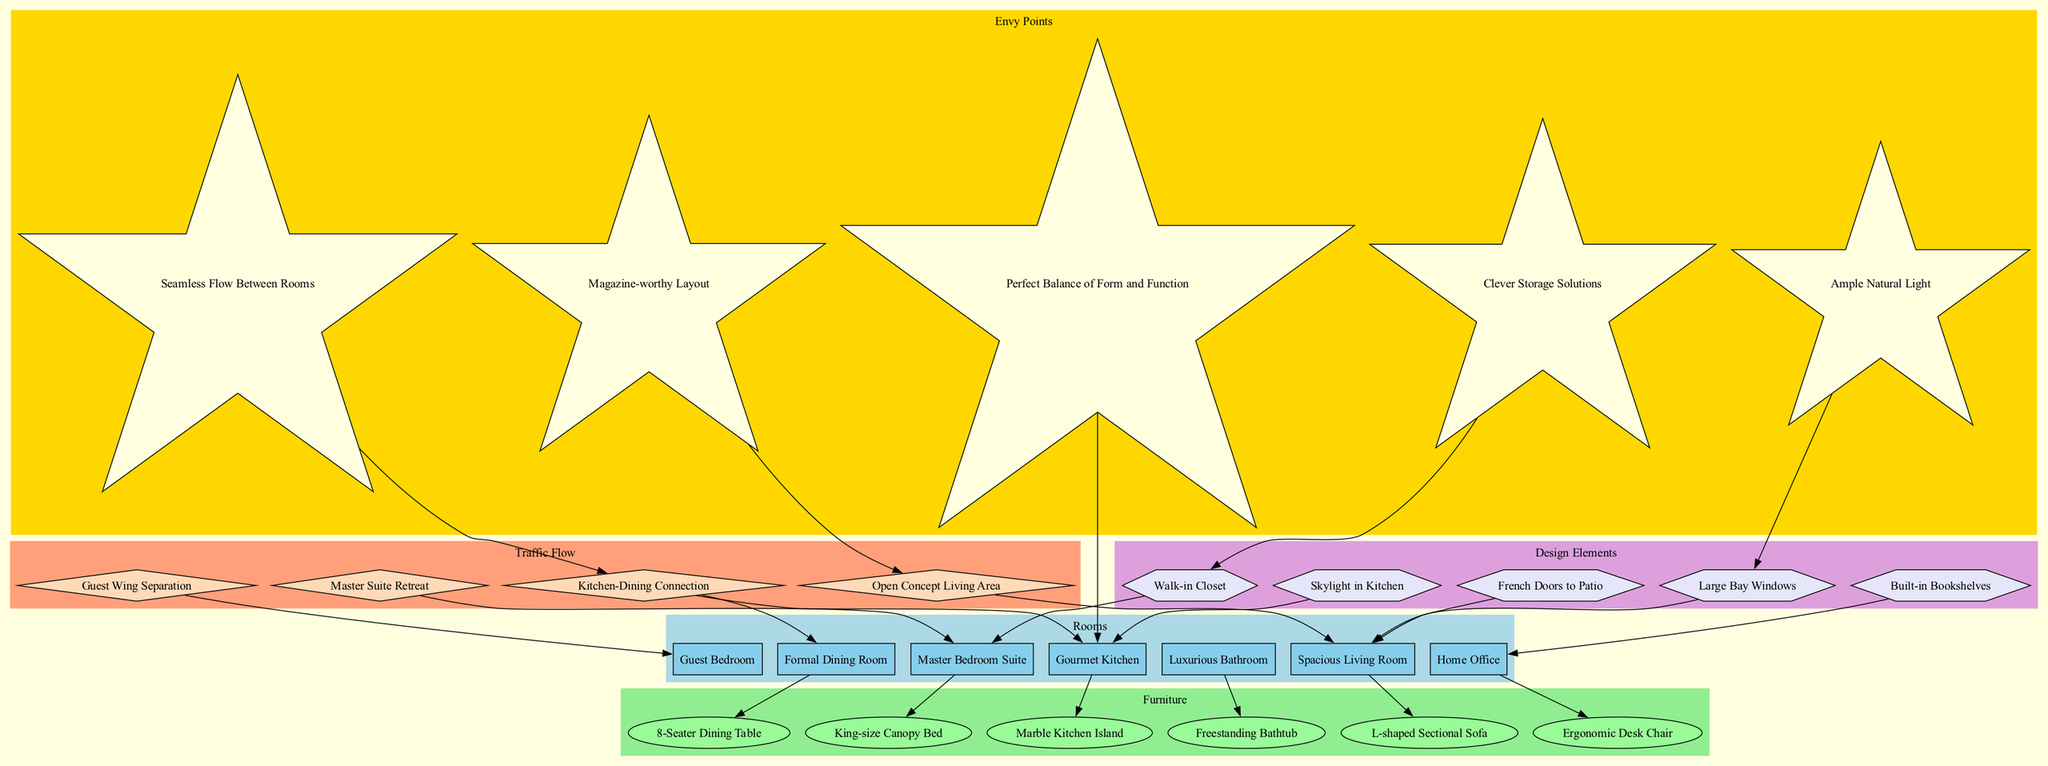How many rooms are represented in the diagram? The diagram lists the following rooms: Spacious Living Room, Gourmet Kitchen, Formal Dining Room, Master Bedroom Suite, Guest Bedroom, Home Office, and Luxurious Bathroom. Counting these, there are a total of 7 rooms.
Answer: 7 What is connected to the L-shaped Sectional Sofa? The L-shaped Sectional Sofa is connected to the Spacious Living Room in the diagram, indicating that it is placed within this room.
Answer: Spacious Living Room Which room features the Marble Kitchen Island? The Marble Kitchen Island is connected to the Gourmet Kitchen, which shows it is located in this area of the house.
Answer: Gourmet Kitchen What element enhances the Ample Natural Light point? The Large Bay Windows are linked to the Ample Natural Light envy point, indicating that they contribute to the lighting feature in the home.
Answer: Large Bay Windows Which two rooms are connected by the Kitchen-Dining Connection traffic flow? The Kitchen-Dining Connection directly connects the Gourmet Kitchen and the Formal Dining Room, establishing a clear link for movement and flow between these spaces.
Answer: Gourmet Kitchen, Formal Dining Room How many design elements are listed in the diagram? The diagram includes five design elements: Large Bay Windows, Skylight in Kitchen, French Doors to Patio, Walk-in Closet, and Built-in Bookshelves. Thus, the total number is 5.
Answer: 5 What is the separation structure for guest accommodation? The Guest Wing Separation is indicated in the diagram as the structure that separates the Guest Bedroom from other areas of the home, ensuring privacy for guests.
Answer: Guest Wing Separation Which furniture is part of the Master Bedroom Suite? The King-size Canopy Bed is specifically linked to the Master Bedroom Suite in the diagram, showing it is a key piece of furniture in this room.
Answer: King-size Canopy Bed Which envy point is related to the design of the Gourmet Kitchen? The Perfect Balance of Form and Function is connected to the Gourmet Kitchen, indicating that this design feature enhances the functionality and aesthetics of the kitchen space.
Answer: Perfect Balance of Form and Function 